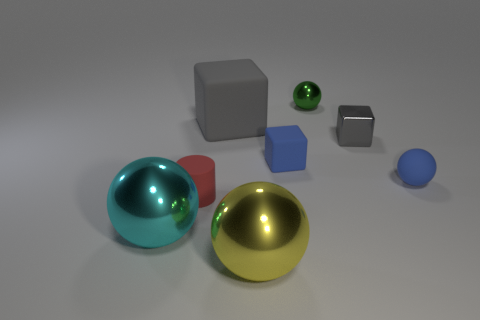Subtract all matte cubes. How many cubes are left? 1 Add 1 big shiny things. How many objects exist? 9 Subtract all blue cubes. How many cubes are left? 2 Subtract all brown cylinders. How many gray cubes are left? 2 Subtract all tiny shiny balls. Subtract all large gray blocks. How many objects are left? 6 Add 6 large yellow metal balls. How many large yellow metal balls are left? 7 Add 7 tiny blocks. How many tiny blocks exist? 9 Subtract 1 blue cubes. How many objects are left? 7 Subtract all cubes. How many objects are left? 5 Subtract 2 blocks. How many blocks are left? 1 